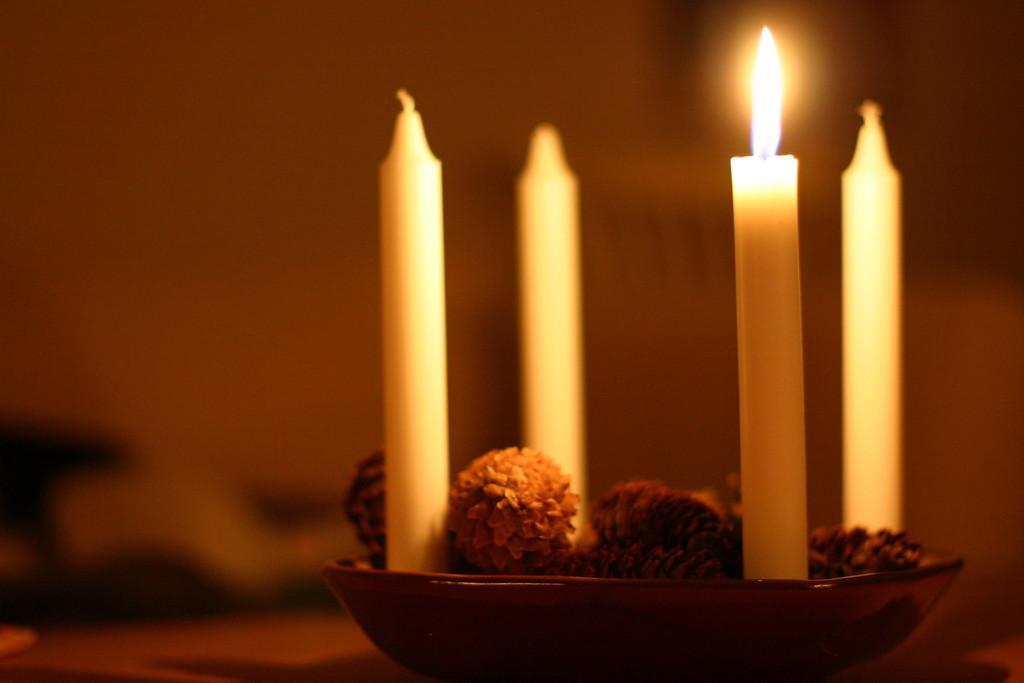Could you give a brief overview of what you see in this image? In this image I can see a brown color plate and in it I can see few candles and few other things. I can also see this image is little bit blurry from background. 